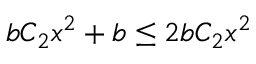<formula> <loc_0><loc_0><loc_500><loc_500>b C _ { 2 } x ^ { 2 } + b \leq 2 b C _ { 2 } x ^ { 2 }</formula> 